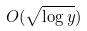Convert formula to latex. <formula><loc_0><loc_0><loc_500><loc_500>O ( \sqrt { \log y } )</formula> 